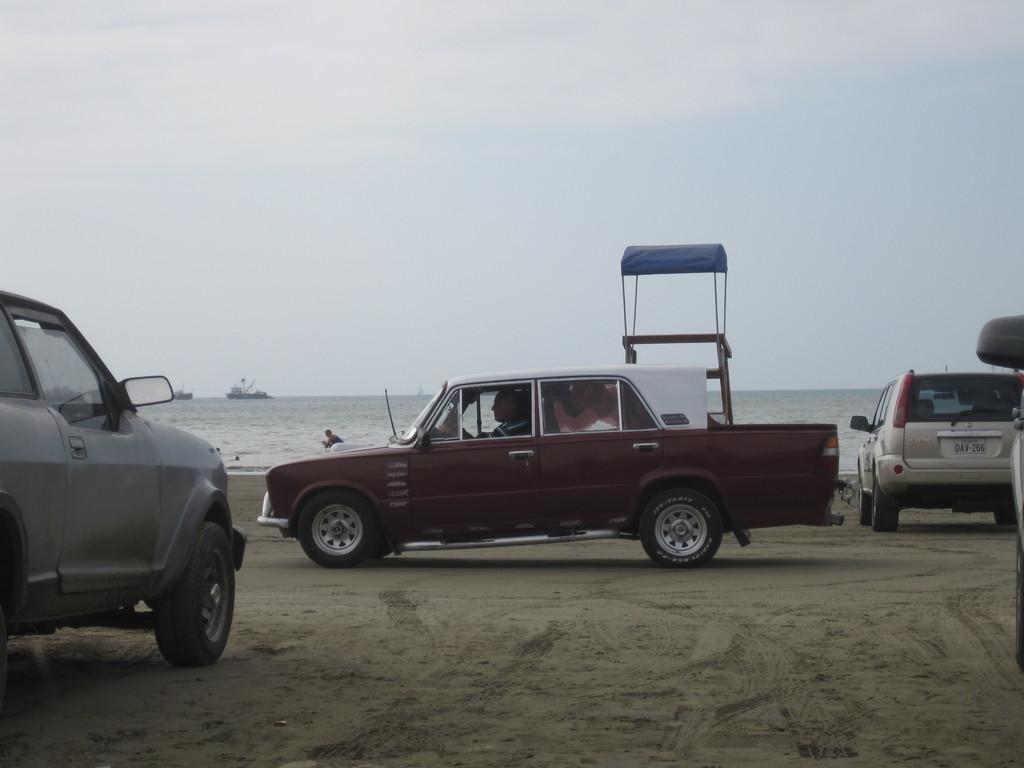Could you give a brief overview of what you see in this image? In this image we can see these cars parked on the sand, we can see water, stand, ships floating on the water and the plain sky in the background. 